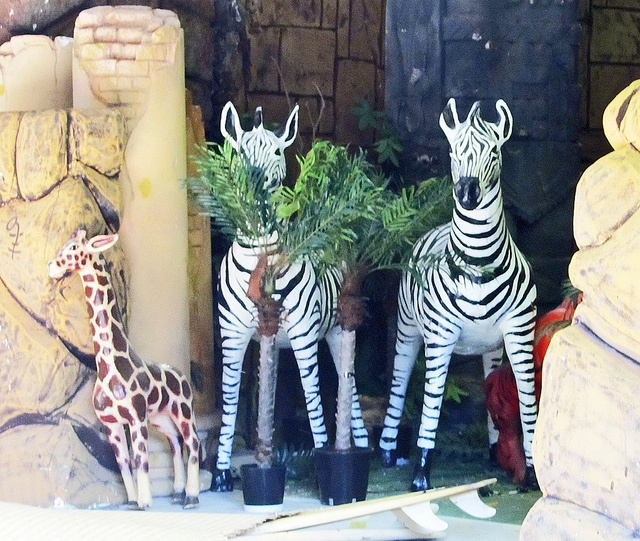Describe the objects in this image and their specific colors. I can see zebra in pink, white, black, lightblue, and navy tones, zebra in pink, lightgray, gray, black, and lightblue tones, potted plant in pink, teal, green, and darkgray tones, giraffe in pink, lightgray, gray, darkgray, and brown tones, and potted plant in pink, navy, teal, and black tones in this image. 